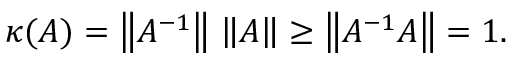<formula> <loc_0><loc_0><loc_500><loc_500>\kappa ( A ) = \left \| A ^ { - 1 } \right \| \, \left \| A \right \| \geq \left \| A ^ { - 1 } A \right \| = 1 .</formula> 